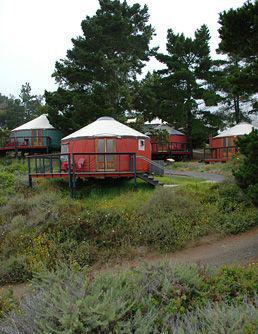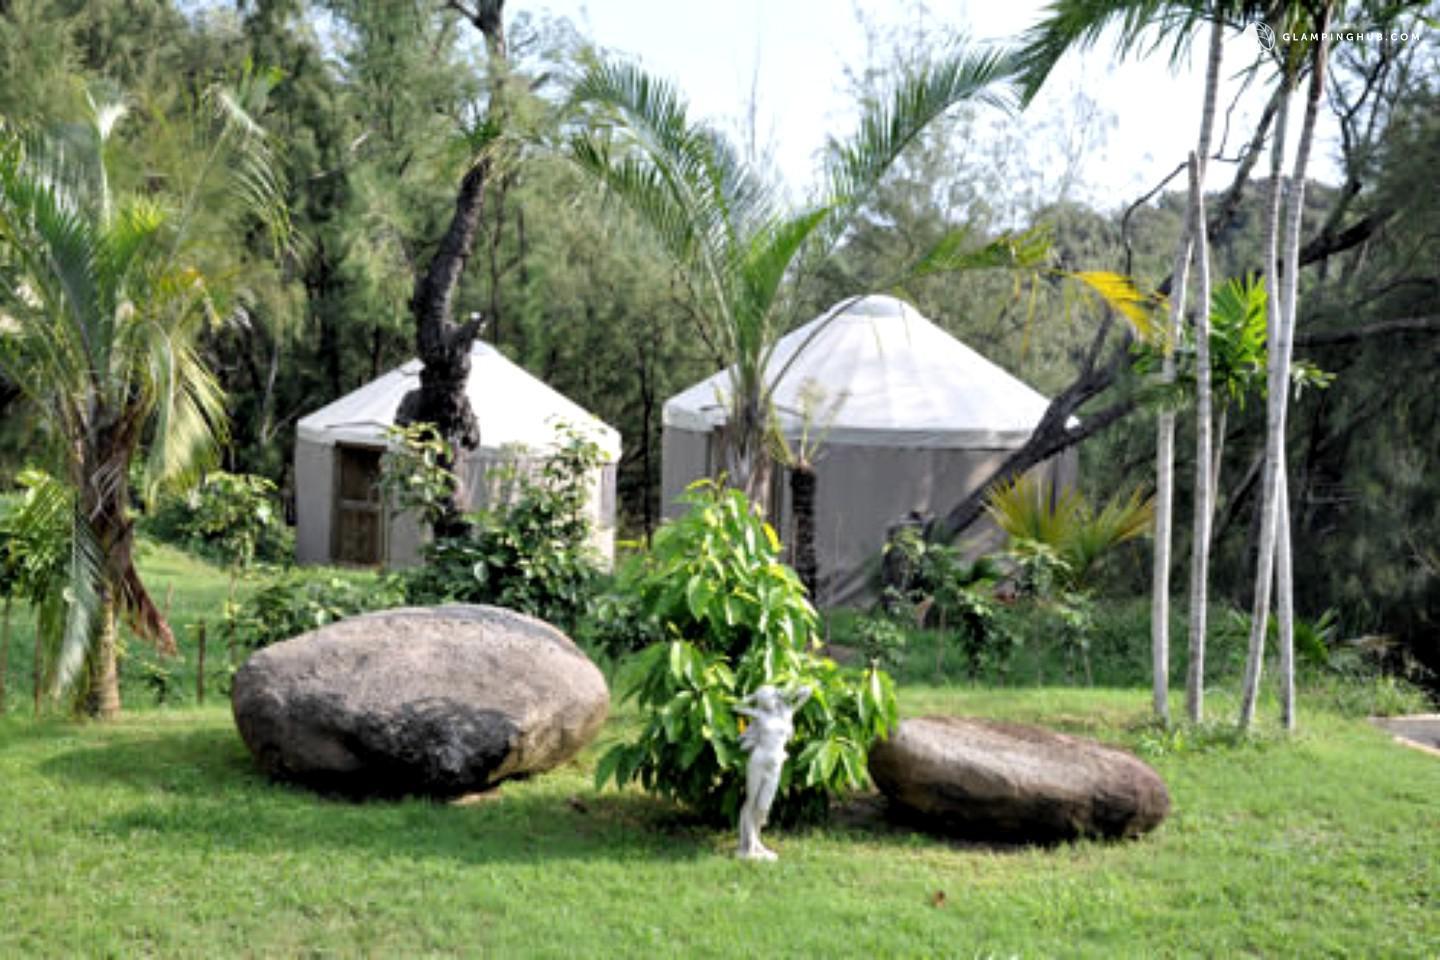The first image is the image on the left, the second image is the image on the right. Analyze the images presented: Is the assertion "There are four or more yurts in the left image and some of them are red." valid? Answer yes or no. Yes. The first image is the image on the left, the second image is the image on the right. Assess this claim about the two images: "Two round houses with white roofs and walls are in one image.". Correct or not? Answer yes or no. Yes. 